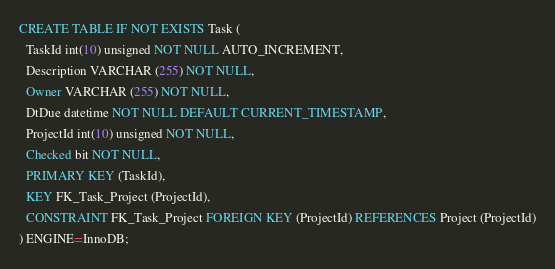Convert code to text. <code><loc_0><loc_0><loc_500><loc_500><_SQL_>CREATE TABLE IF NOT EXISTS Task (
  TaskId int(10) unsigned NOT NULL AUTO_INCREMENT,
  Description VARCHAR (255) NOT NULL,
  Owner VARCHAR (255) NOT NULL,
  DtDue datetime NOT NULL DEFAULT CURRENT_TIMESTAMP,
  ProjectId int(10) unsigned NOT NULL,
  Checked bit NOT NULL,
  PRIMARY KEY (TaskId),
  KEY FK_Task_Project (ProjectId),
  CONSTRAINT FK_Task_Project FOREIGN KEY (ProjectId) REFERENCES Project (ProjectId)
) ENGINE=InnoDB;
</code> 